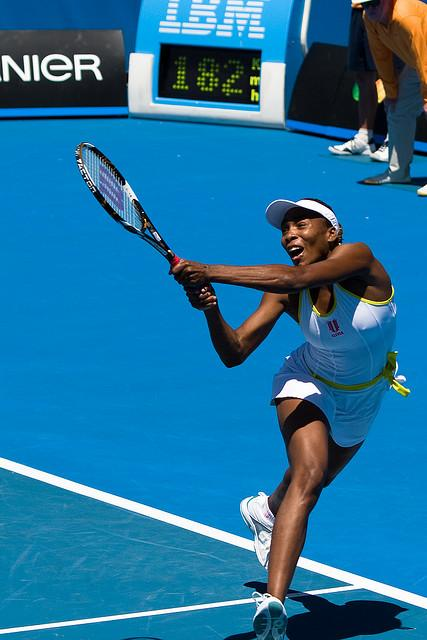What is her sister's name?

Choices:
A) naomi
B) serena
C) anna
D) venus serena 